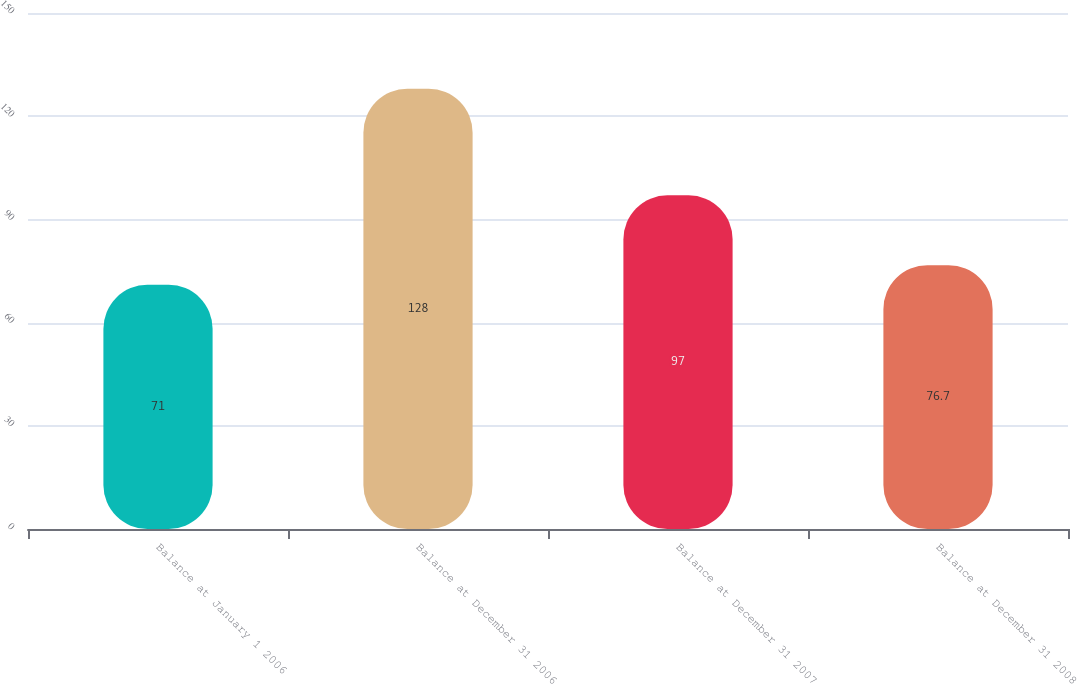Convert chart. <chart><loc_0><loc_0><loc_500><loc_500><bar_chart><fcel>Balance at January 1 2006<fcel>Balance at December 31 2006<fcel>Balance at December 31 2007<fcel>Balance at December 31 2008<nl><fcel>71<fcel>128<fcel>97<fcel>76.7<nl></chart> 